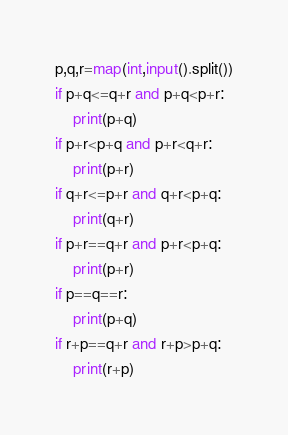Convert code to text. <code><loc_0><loc_0><loc_500><loc_500><_Python_>p,q,r=map(int,input().split())
if p+q<=q+r and p+q<p+r:
    print(p+q)
if p+r<p+q and p+r<q+r:
    print(p+r)
if q+r<=p+r and q+r<p+q:
    print(q+r)
if p+r==q+r and p+r<p+q:
    print(p+r)
if p==q==r:
    print(p+q)
if r+p==q+r and r+p>p+q:
    print(r+p)</code> 